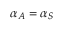<formula> <loc_0><loc_0><loc_500><loc_500>\alpha _ { A } = \alpha _ { S }</formula> 